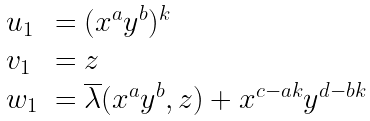<formula> <loc_0><loc_0><loc_500><loc_500>\begin{array} { l l } u _ { 1 } & = ( x ^ { a } y ^ { b } ) ^ { k } \\ v _ { 1 } & = z \\ w _ { 1 } & = \overline { \lambda } ( x ^ { a } y ^ { b } , z ) + x ^ { c - a k } y ^ { d - b k } \end{array}</formula> 